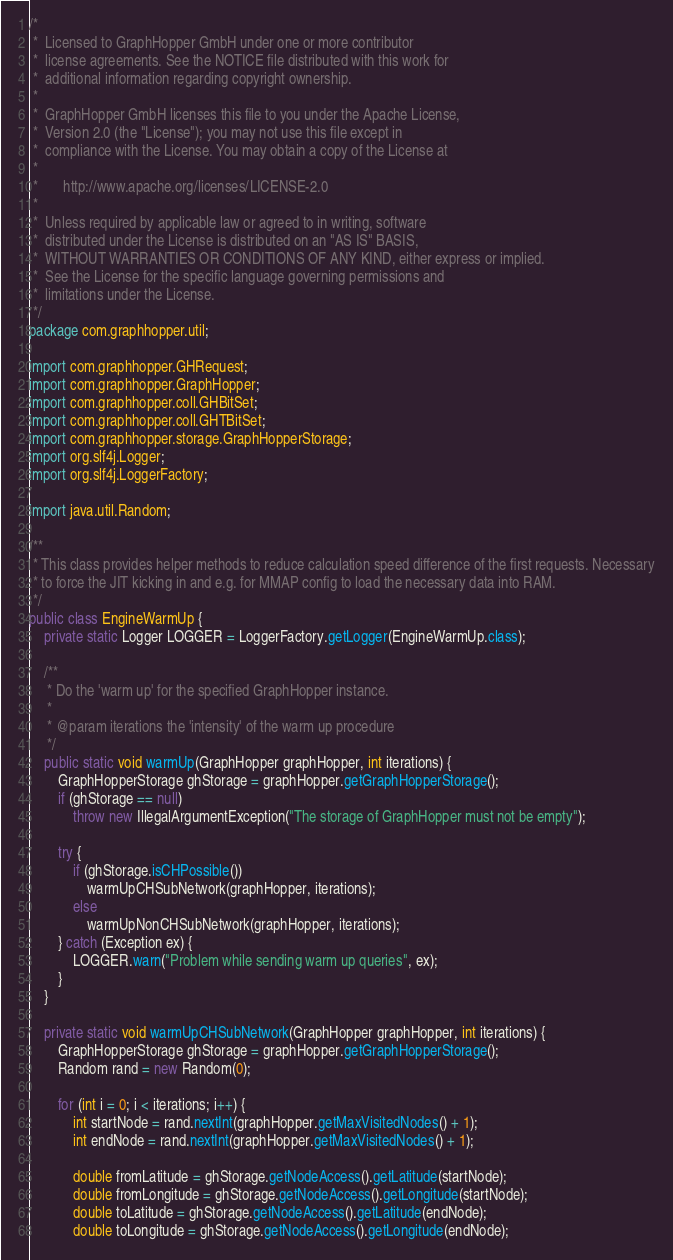Convert code to text. <code><loc_0><loc_0><loc_500><loc_500><_Java_>/*
 *  Licensed to GraphHopper GmbH under one or more contributor
 *  license agreements. See the NOTICE file distributed with this work for
 *  additional information regarding copyright ownership.
 *
 *  GraphHopper GmbH licenses this file to you under the Apache License,
 *  Version 2.0 (the "License"); you may not use this file except in
 *  compliance with the License. You may obtain a copy of the License at
 *
 *       http://www.apache.org/licenses/LICENSE-2.0
 *
 *  Unless required by applicable law or agreed to in writing, software
 *  distributed under the License is distributed on an "AS IS" BASIS,
 *  WITHOUT WARRANTIES OR CONDITIONS OF ANY KIND, either express or implied.
 *  See the License for the specific language governing permissions and
 *  limitations under the License.
 */
package com.graphhopper.util;

import com.graphhopper.GHRequest;
import com.graphhopper.GraphHopper;
import com.graphhopper.coll.GHBitSet;
import com.graphhopper.coll.GHTBitSet;
import com.graphhopper.storage.GraphHopperStorage;
import org.slf4j.Logger;
import org.slf4j.LoggerFactory;

import java.util.Random;

/**
 * This class provides helper methods to reduce calculation speed difference of the first requests. Necessary
 * to force the JIT kicking in and e.g. for MMAP config to load the necessary data into RAM.
 */
public class EngineWarmUp {
    private static Logger LOGGER = LoggerFactory.getLogger(EngineWarmUp.class);

    /**
     * Do the 'warm up' for the specified GraphHopper instance.
     *
     * @param iterations the 'intensity' of the warm up procedure
     */
    public static void warmUp(GraphHopper graphHopper, int iterations) {
        GraphHopperStorage ghStorage = graphHopper.getGraphHopperStorage();
        if (ghStorage == null)
            throw new IllegalArgumentException("The storage of GraphHopper must not be empty");

        try {
            if (ghStorage.isCHPossible())
                warmUpCHSubNetwork(graphHopper, iterations);
            else
                warmUpNonCHSubNetwork(graphHopper, iterations);
        } catch (Exception ex) {
            LOGGER.warn("Problem while sending warm up queries", ex);
        }
    }

    private static void warmUpCHSubNetwork(GraphHopper graphHopper, int iterations) {
        GraphHopperStorage ghStorage = graphHopper.getGraphHopperStorage();
        Random rand = new Random(0);

        for (int i = 0; i < iterations; i++) {
            int startNode = rand.nextInt(graphHopper.getMaxVisitedNodes() + 1);
            int endNode = rand.nextInt(graphHopper.getMaxVisitedNodes() + 1);

            double fromLatitude = ghStorage.getNodeAccess().getLatitude(startNode);
            double fromLongitude = ghStorage.getNodeAccess().getLongitude(startNode);
            double toLatitude = ghStorage.getNodeAccess().getLatitude(endNode);
            double toLongitude = ghStorage.getNodeAccess().getLongitude(endNode);
</code> 